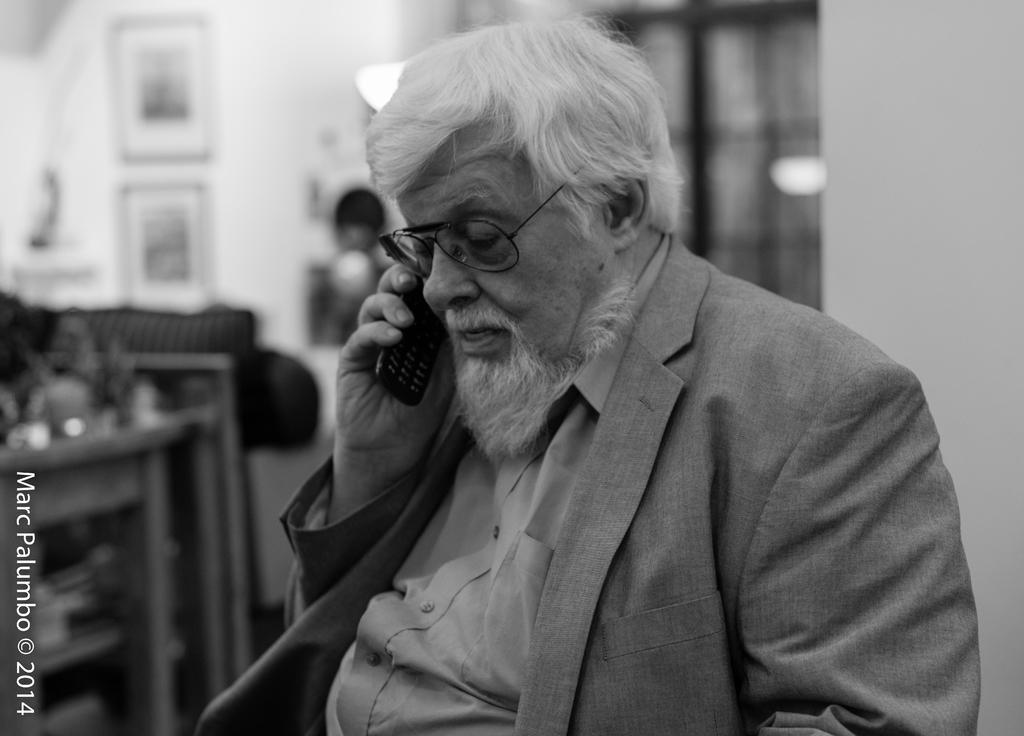In one or two sentences, can you explain what this image depicts? In this picture we can see a man wearing a spectacle and holding a phone in his hand. There is a watermark, numbers and some text on the left side. We can see the lights and other objects in the background. Background is blurry. 